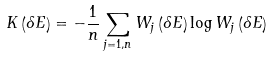Convert formula to latex. <formula><loc_0><loc_0><loc_500><loc_500>K \left ( \delta E \right ) = - \frac { 1 } { n } \sum _ { j = 1 , n } W _ { j } \left ( \delta E \right ) \log W _ { j } \left ( \delta E \right )</formula> 